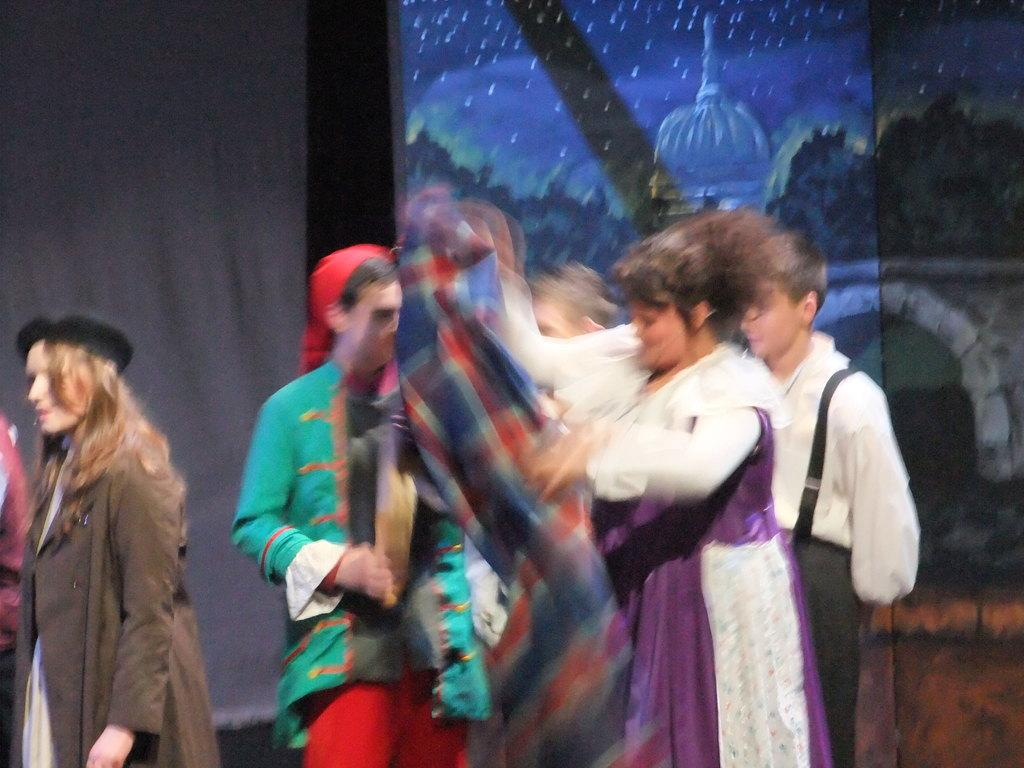How many people are in the image? There is a group of people in the image. What is one person holding in the image? One person is holding a cloth. What can be seen in the background of the image? There is a board and a curtain in the background of the image. What type of tin is being used to hold the quarter in the image? There is no tin or quarter present in the image. 